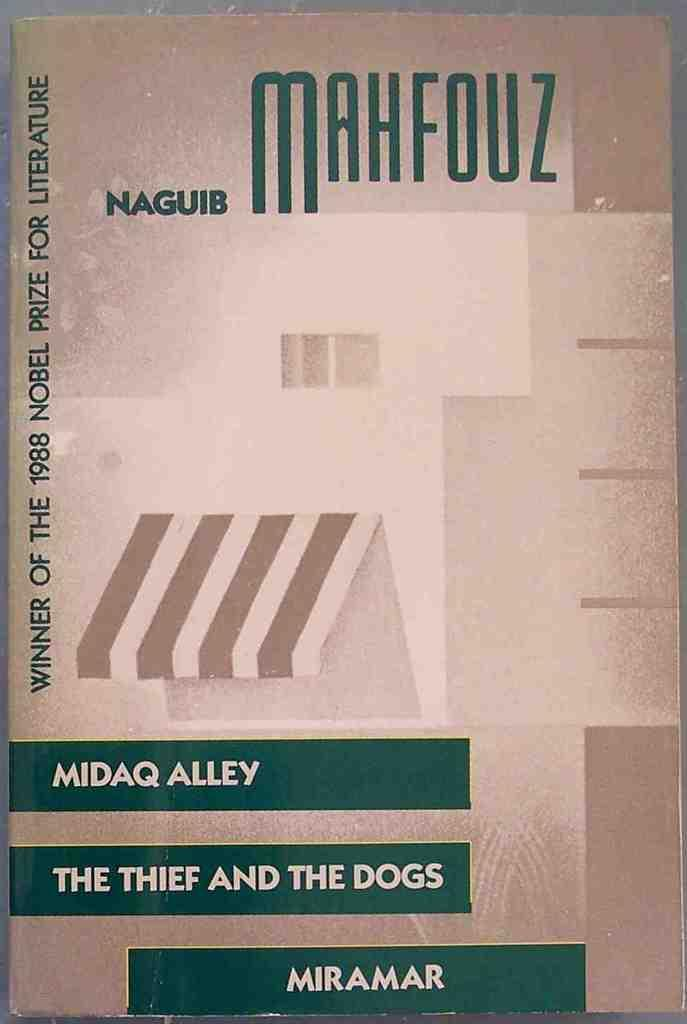<image>
Share a concise interpretation of the image provided. A copy of The Thief and the Dogs claims to be the winner of an award in 1988. 